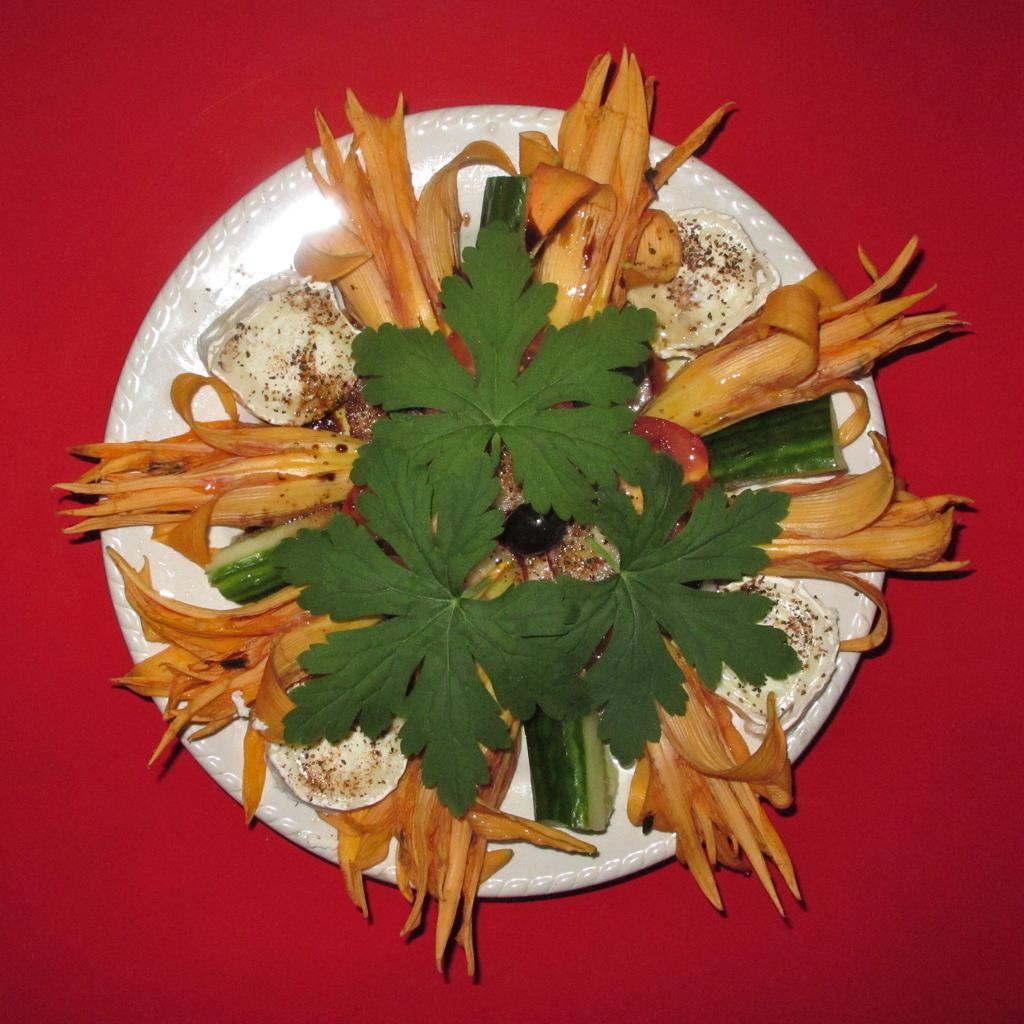What is on the plate that is visible in the image? There is a plate with food items in the image. What is a noticeable characteristic of the food on the plate? Leaves are present on the food. Where is the plate located in the image? The plate is on a platform. How does the friend help wash the dishes in the image? There is no friend present in the image, and no dishes are being washed. 